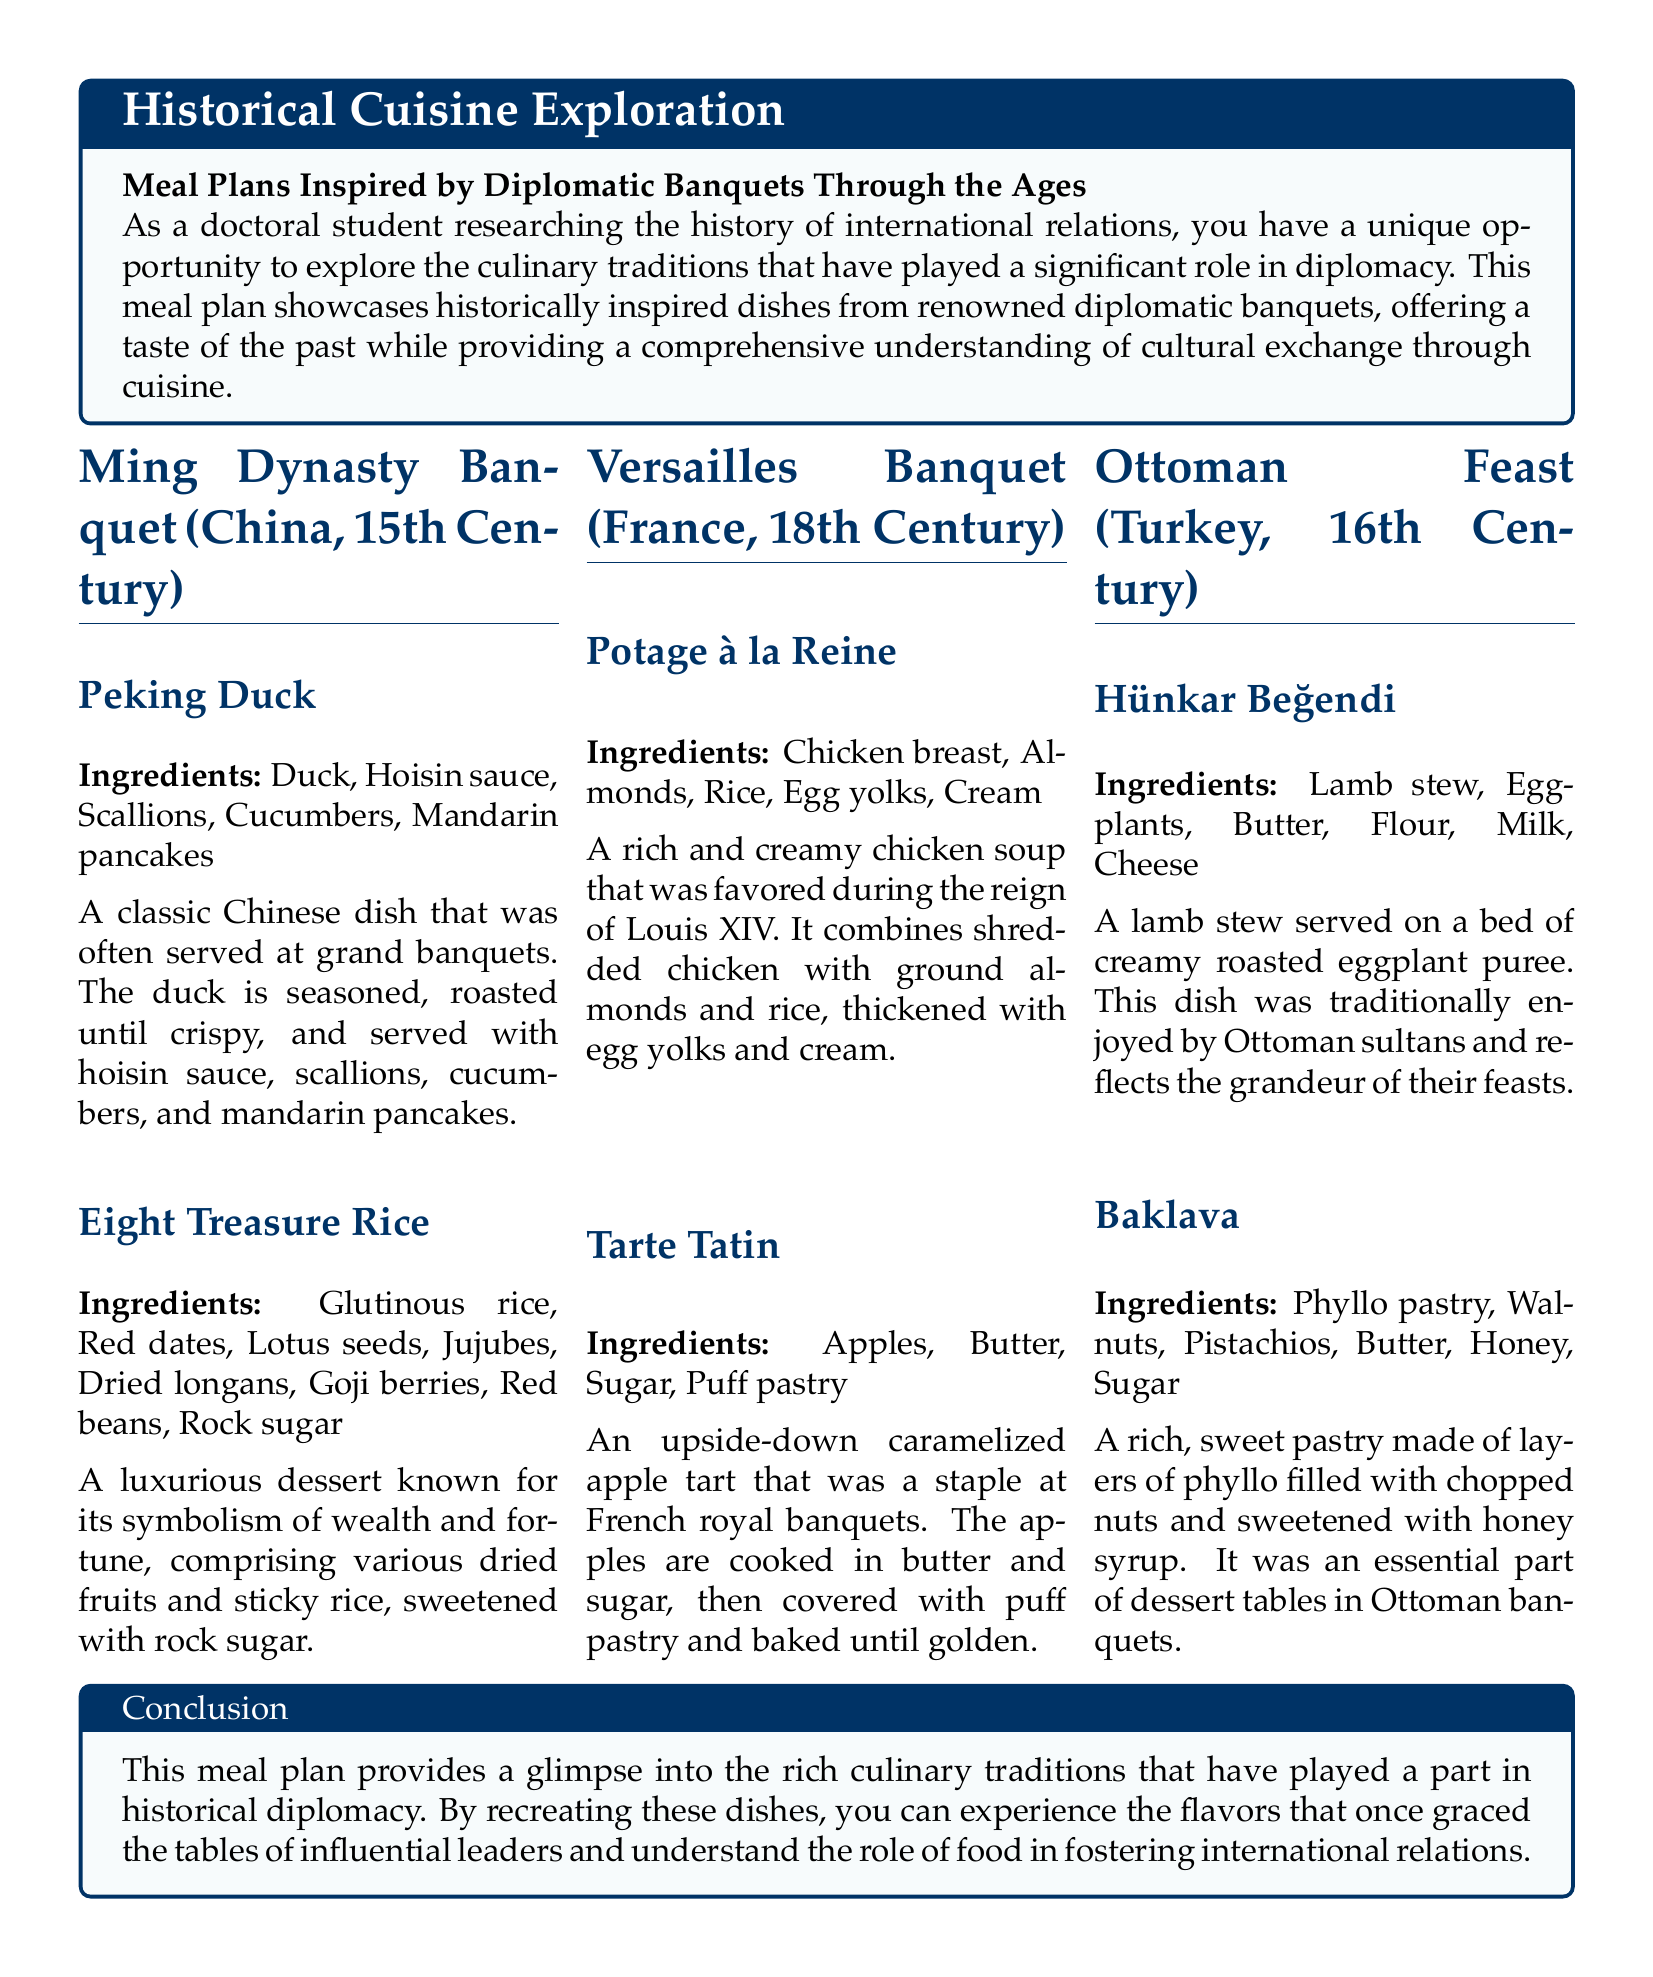What dish is served at the Ming Dynasty Banquet? The Ming Dynasty Banquet features Peking Duck as one of the dishes.
Answer: Peking Duck What is the main ingredient in Potage à la Reine? Potage à la Reine primarily contains chicken breast.
Answer: Chicken breast What era is the Versailles Banquet from? The Versailles Banquet dates back to the 18th Century.
Answer: 18th Century How many ingredients are used in Eight Treasure Rice? Eight Treasure Rice includes a total of eight different ingredients related to dried fruits and glutinous rice.
Answer: Eight What dessert is made with phyllo pastry in the Ottoman Feast? The dessert made with phyllo pastry in the Ottoman Feast is Baklava.
Answer: Baklava What cultural significance does Eight Treasure Rice have? Eight Treasure Rice symbolizes wealth and fortune in Chinese culture.
Answer: Wealth and fortune What is the main cuisine theme of the meal plan? The meal plan focuses on historical cuisine inspired by diplomatic banquets.
Answer: Historical cuisine Which dish reflects the grandeur of Ottoman feasts? Hünkar Beğendi reflects the grandeur of Ottoman feasts.
Answer: Hünkar Beğendi What is the purpose of recreating these historical dishes? Recreating these dishes allows individuals to experience flavors significant in historical diplomacy.
Answer: Experience flavors 